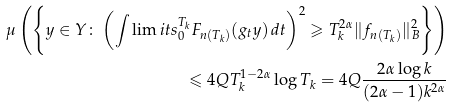Convert formula to latex. <formula><loc_0><loc_0><loc_500><loc_500>\mu \left ( \left \{ y \in Y \colon \left ( \int \lim i t s _ { 0 } ^ { T _ { k } } F _ { n ( T _ { k } ) } ( g _ { t } y ) \, d t \right ) ^ { 2 } \geqslant T _ { k } ^ { 2 \alpha } \| f _ { n ( T _ { k } ) } \| _ { B } ^ { 2 } \right \} \right ) \\ \leqslant 4 Q T _ { k } ^ { 1 - 2 \alpha } \log T _ { k } = 4 Q \frac { 2 \alpha \log k } { ( 2 \alpha - 1 ) k ^ { 2 \alpha } }</formula> 